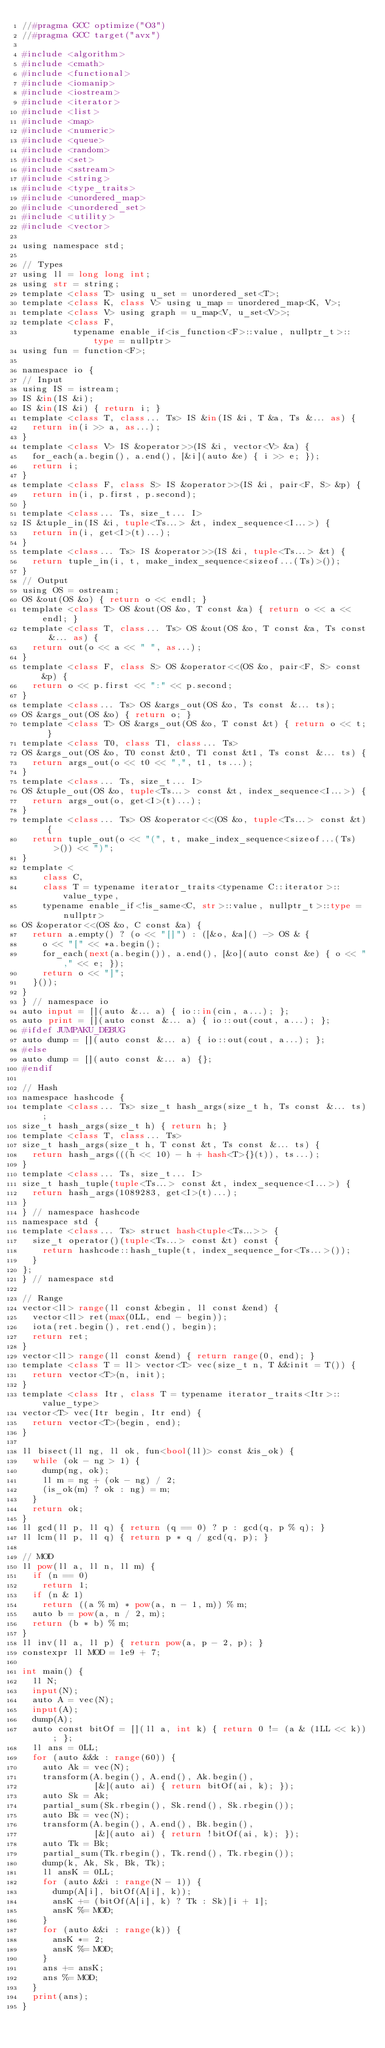<code> <loc_0><loc_0><loc_500><loc_500><_Python_>//#pragma GCC optimize("O3")
//#pragma GCC target("avx")

#include <algorithm>
#include <cmath>
#include <functional>
#include <iomanip>
#include <iostream>
#include <iterator>
#include <list>
#include <map>
#include <numeric>
#include <queue>
#include <random>
#include <set>
#include <sstream>
#include <string>
#include <type_traits>
#include <unordered_map>
#include <unordered_set>
#include <utility>
#include <vector>

using namespace std;

// Types
using ll = long long int;
using str = string;
template <class T> using u_set = unordered_set<T>;
template <class K, class V> using u_map = unordered_map<K, V>;
template <class V> using graph = u_map<V, u_set<V>>;
template <class F,
          typename enable_if<is_function<F>::value, nullptr_t>::type = nullptr>
using fun = function<F>;

namespace io {
// Input
using IS = istream;
IS &in(IS &i);
IS &in(IS &i) { return i; }
template <class T, class... Ts> IS &in(IS &i, T &a, Ts &... as) {
  return in(i >> a, as...);
}
template <class V> IS &operator>>(IS &i, vector<V> &a) {
  for_each(a.begin(), a.end(), [&i](auto &e) { i >> e; });
  return i;
}
template <class F, class S> IS &operator>>(IS &i, pair<F, S> &p) {
  return in(i, p.first, p.second);
}
template <class... Ts, size_t... I>
IS &tuple_in(IS &i, tuple<Ts...> &t, index_sequence<I...>) {
  return in(i, get<I>(t)...);
}
template <class... Ts> IS &operator>>(IS &i, tuple<Ts...> &t) {
  return tuple_in(i, t, make_index_sequence<sizeof...(Ts)>());
}
// Output
using OS = ostream;
OS &out(OS &o) { return o << endl; }
template <class T> OS &out(OS &o, T const &a) { return o << a << endl; }
template <class T, class... Ts> OS &out(OS &o, T const &a, Ts const &... as) {
  return out(o << a << " ", as...);
}
template <class F, class S> OS &operator<<(OS &o, pair<F, S> const &p) {
  return o << p.first << ":" << p.second;
}
template <class... Ts> OS &args_out(OS &o, Ts const &... ts);
OS &args_out(OS &o) { return o; }
template <class T> OS &args_out(OS &o, T const &t) { return o << t; }
template <class T0, class T1, class... Ts>
OS &args_out(OS &o, T0 const &t0, T1 const &t1, Ts const &... ts) {
  return args_out(o << t0 << ",", t1, ts...);
}
template <class... Ts, size_t... I>
OS &tuple_out(OS &o, tuple<Ts...> const &t, index_sequence<I...>) {
  return args_out(o, get<I>(t)...);
}
template <class... Ts> OS &operator<<(OS &o, tuple<Ts...> const &t) {
  return tuple_out(o << "(", t, make_index_sequence<sizeof...(Ts)>()) << ")";
}
template <
    class C,
    class T = typename iterator_traits<typename C::iterator>::value_type,
    typename enable_if<!is_same<C, str>::value, nullptr_t>::type = nullptr>
OS &operator<<(OS &o, C const &a) {
  return a.empty() ? (o << "[]") : ([&o, &a]() -> OS & {
    o << "[" << *a.begin();
    for_each(next(a.begin()), a.end(), [&o](auto const &e) { o << "," << e; });
    return o << "]";
  }());
}
} // namespace io
auto input = [](auto &... a) { io::in(cin, a...); };
auto print = [](auto const &... a) { io::out(cout, a...); };
#ifdef JUMPAKU_DEBUG
auto dump = [](auto const &... a) { io::out(cout, a...); };
#else
auto dump = [](auto const &... a) {};
#endif

// Hash
namespace hashcode {
template <class... Ts> size_t hash_args(size_t h, Ts const &... ts);
size_t hash_args(size_t h) { return h; }
template <class T, class... Ts>
size_t hash_args(size_t h, T const &t, Ts const &... ts) {
  return hash_args(((h << 10) - h + hash<T>{}(t)), ts...);
}
template <class... Ts, size_t... I>
size_t hash_tuple(tuple<Ts...> const &t, index_sequence<I...>) {
  return hash_args(1089283, get<I>(t)...);
}
} // namespace hashcode
namespace std {
template <class... Ts> struct hash<tuple<Ts...>> {
  size_t operator()(tuple<Ts...> const &t) const {
    return hashcode::hash_tuple(t, index_sequence_for<Ts...>());
  }
};
} // namespace std

// Range
vector<ll> range(ll const &begin, ll const &end) {
  vector<ll> ret(max(0LL, end - begin));
  iota(ret.begin(), ret.end(), begin);
  return ret;
}
vector<ll> range(ll const &end) { return range(0, end); }
template <class T = ll> vector<T> vec(size_t n, T &&init = T()) {
  return vector<T>(n, init);
}
template <class Itr, class T = typename iterator_traits<Itr>::value_type>
vector<T> vec(Itr begin, Itr end) {
  return vector<T>(begin, end);
}

ll bisect(ll ng, ll ok, fun<bool(ll)> const &is_ok) {
  while (ok - ng > 1) {
    dump(ng, ok);
    ll m = ng + (ok - ng) / 2;
    (is_ok(m) ? ok : ng) = m;
  }
  return ok;
}
ll gcd(ll p, ll q) { return (q == 0) ? p : gcd(q, p % q); }
ll lcm(ll p, ll q) { return p * q / gcd(q, p); }

// MOD
ll pow(ll a, ll n, ll m) {
  if (n == 0)
    return 1;
  if (n & 1)
    return ((a % m) * pow(a, n - 1, m)) % m;
  auto b = pow(a, n / 2, m);
  return (b * b) % m;
}
ll inv(ll a, ll p) { return pow(a, p - 2, p); }
constexpr ll MOD = 1e9 + 7;

int main() {
  ll N;
  input(N);
  auto A = vec(N);
  input(A);
  dump(A);
  auto const bitOf = [](ll a, int k) { return 0 != (a & (1LL << k)); };
  ll ans = 0LL;
  for (auto &&k : range(60)) {
    auto Ak = vec(N);
    transform(A.begin(), A.end(), Ak.begin(),
              [&](auto ai) { return bitOf(ai, k); });
    auto Sk = Ak;
    partial_sum(Sk.rbegin(), Sk.rend(), Sk.rbegin());
    auto Bk = vec(N);
    transform(A.begin(), A.end(), Bk.begin(),
              [&](auto ai) { return !bitOf(ai, k); });
    auto Tk = Bk;
    partial_sum(Tk.rbegin(), Tk.rend(), Tk.rbegin());
    dump(k, Ak, Sk, Bk, Tk);
    ll ansK = 0LL;
    for (auto &&i : range(N - 1)) {
      dump(A[i], bitOf(A[i], k));
      ansK += (bitOf(A[i], k) ? Tk : Sk)[i + 1];
      ansK %= MOD;
    }
    for (auto &&i : range(k)) {
      ansK *= 2;
      ansK %= MOD;
    }
    ans += ansK;
    ans %= MOD;
  }
  print(ans);
}
</code> 